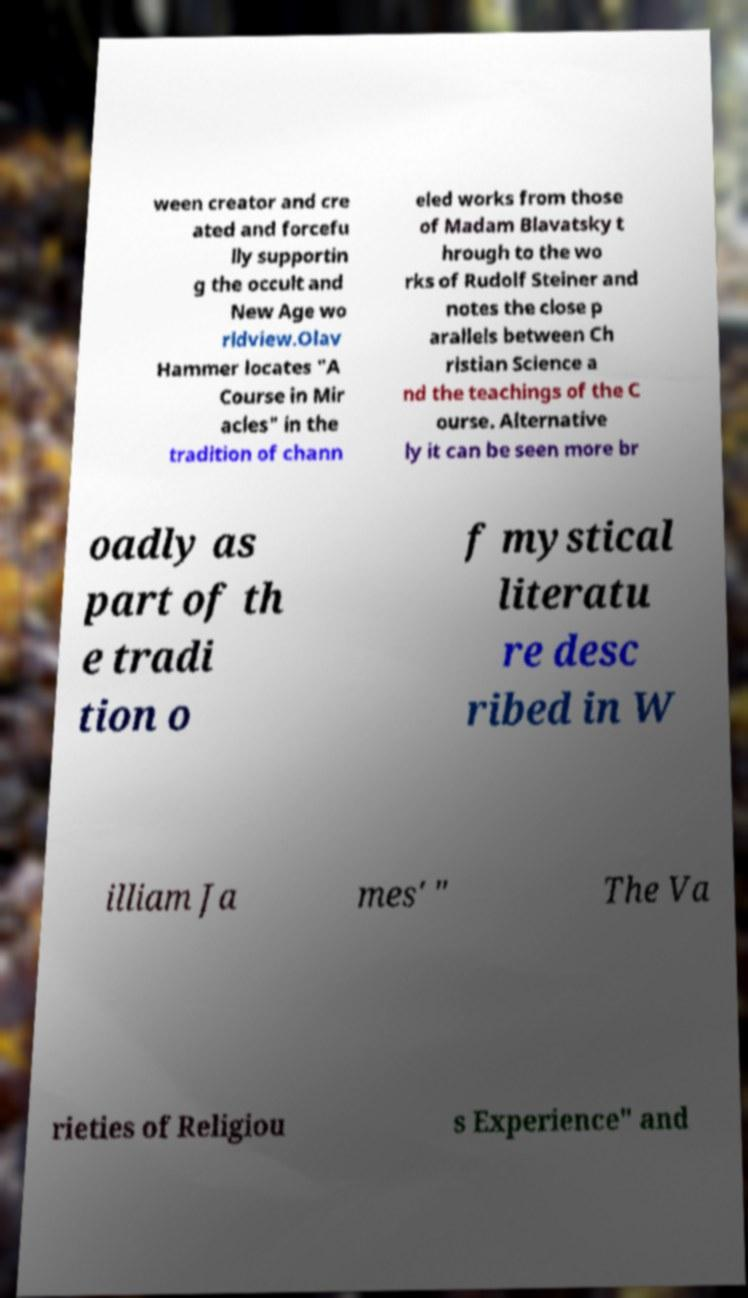There's text embedded in this image that I need extracted. Can you transcribe it verbatim? ween creator and cre ated and forcefu lly supportin g the occult and New Age wo rldview.Olav Hammer locates "A Course in Mir acles" in the tradition of chann eled works from those of Madam Blavatsky t hrough to the wo rks of Rudolf Steiner and notes the close p arallels between Ch ristian Science a nd the teachings of the C ourse. Alternative ly it can be seen more br oadly as part of th e tradi tion o f mystical literatu re desc ribed in W illiam Ja mes' " The Va rieties of Religiou s Experience" and 